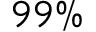<formula> <loc_0><loc_0><loc_500><loc_500>9 9 \%</formula> 